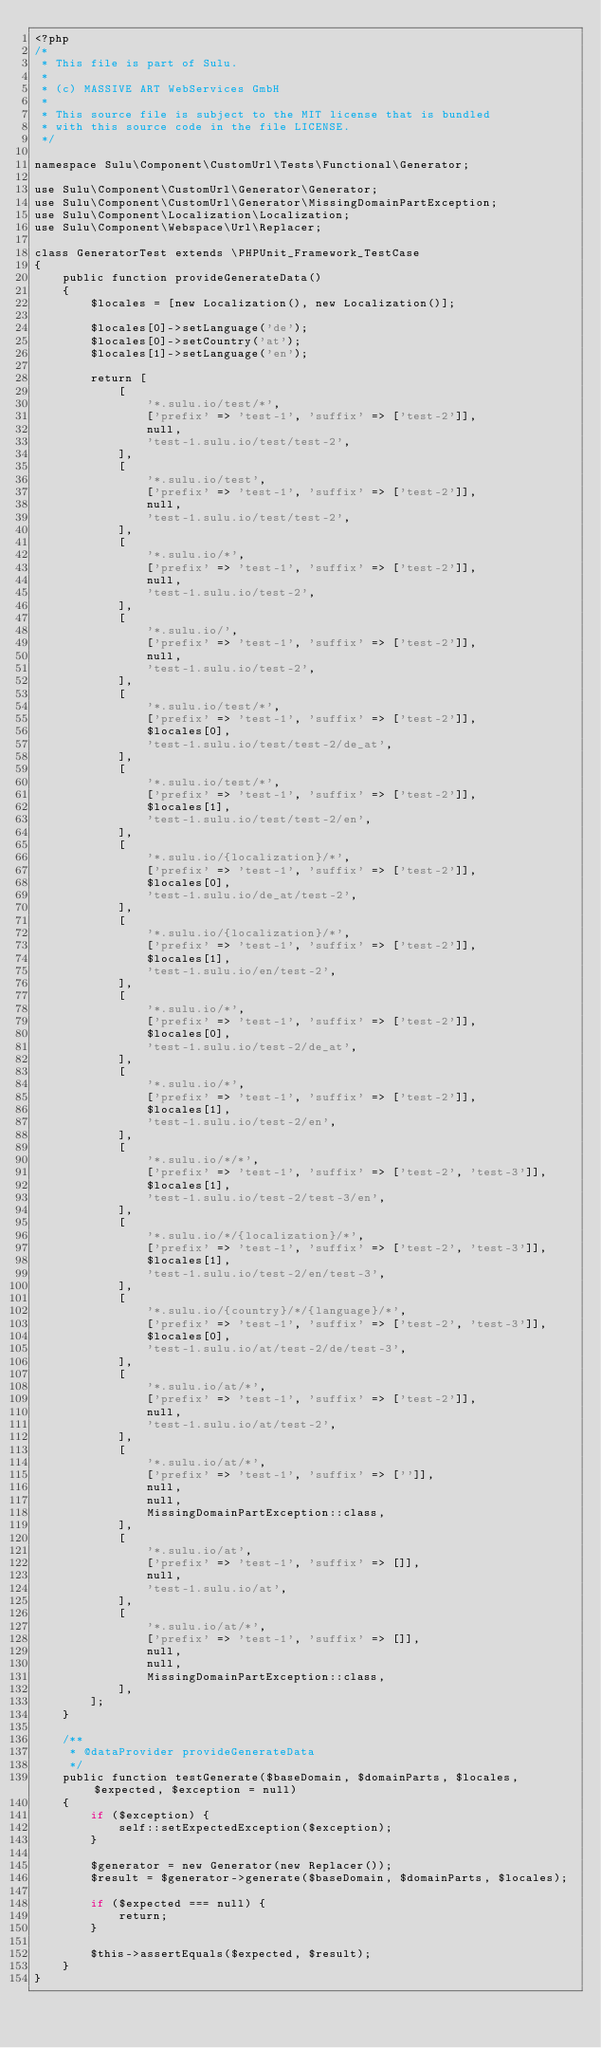<code> <loc_0><loc_0><loc_500><loc_500><_PHP_><?php
/*
 * This file is part of Sulu.
 *
 * (c) MASSIVE ART WebServices GmbH
 *
 * This source file is subject to the MIT license that is bundled
 * with this source code in the file LICENSE.
 */

namespace Sulu\Component\CustomUrl\Tests\Functional\Generator;

use Sulu\Component\CustomUrl\Generator\Generator;
use Sulu\Component\CustomUrl\Generator\MissingDomainPartException;
use Sulu\Component\Localization\Localization;
use Sulu\Component\Webspace\Url\Replacer;

class GeneratorTest extends \PHPUnit_Framework_TestCase
{
    public function provideGenerateData()
    {
        $locales = [new Localization(), new Localization()];

        $locales[0]->setLanguage('de');
        $locales[0]->setCountry('at');
        $locales[1]->setLanguage('en');

        return [
            [
                '*.sulu.io/test/*',
                ['prefix' => 'test-1', 'suffix' => ['test-2']],
                null,
                'test-1.sulu.io/test/test-2',
            ],
            [
                '*.sulu.io/test',
                ['prefix' => 'test-1', 'suffix' => ['test-2']],
                null,
                'test-1.sulu.io/test/test-2',
            ],
            [
                '*.sulu.io/*',
                ['prefix' => 'test-1', 'suffix' => ['test-2']],
                null,
                'test-1.sulu.io/test-2',
            ],
            [
                '*.sulu.io/',
                ['prefix' => 'test-1', 'suffix' => ['test-2']],
                null,
                'test-1.sulu.io/test-2',
            ],
            [
                '*.sulu.io/test/*',
                ['prefix' => 'test-1', 'suffix' => ['test-2']],
                $locales[0],
                'test-1.sulu.io/test/test-2/de_at',
            ],
            [
                '*.sulu.io/test/*',
                ['prefix' => 'test-1', 'suffix' => ['test-2']],
                $locales[1],
                'test-1.sulu.io/test/test-2/en',
            ],
            [
                '*.sulu.io/{localization}/*',
                ['prefix' => 'test-1', 'suffix' => ['test-2']],
                $locales[0],
                'test-1.sulu.io/de_at/test-2',
            ],
            [
                '*.sulu.io/{localization}/*',
                ['prefix' => 'test-1', 'suffix' => ['test-2']],
                $locales[1],
                'test-1.sulu.io/en/test-2',
            ],
            [
                '*.sulu.io/*',
                ['prefix' => 'test-1', 'suffix' => ['test-2']],
                $locales[0],
                'test-1.sulu.io/test-2/de_at',
            ],
            [
                '*.sulu.io/*',
                ['prefix' => 'test-1', 'suffix' => ['test-2']],
                $locales[1],
                'test-1.sulu.io/test-2/en',
            ],
            [
                '*.sulu.io/*/*',
                ['prefix' => 'test-1', 'suffix' => ['test-2', 'test-3']],
                $locales[1],
                'test-1.sulu.io/test-2/test-3/en',
            ],
            [
                '*.sulu.io/*/{localization}/*',
                ['prefix' => 'test-1', 'suffix' => ['test-2', 'test-3']],
                $locales[1],
                'test-1.sulu.io/test-2/en/test-3',
            ],
            [
                '*.sulu.io/{country}/*/{language}/*',
                ['prefix' => 'test-1', 'suffix' => ['test-2', 'test-3']],
                $locales[0],
                'test-1.sulu.io/at/test-2/de/test-3',
            ],
            [
                '*.sulu.io/at/*',
                ['prefix' => 'test-1', 'suffix' => ['test-2']],
                null,
                'test-1.sulu.io/at/test-2',
            ],
            [
                '*.sulu.io/at/*',
                ['prefix' => 'test-1', 'suffix' => ['']],
                null,
                null,
                MissingDomainPartException::class,
            ],
            [
                '*.sulu.io/at',
                ['prefix' => 'test-1', 'suffix' => []],
                null,
                'test-1.sulu.io/at',
            ],
            [
                '*.sulu.io/at/*',
                ['prefix' => 'test-1', 'suffix' => []],
                null,
                null,
                MissingDomainPartException::class,
            ],
        ];
    }

    /**
     * @dataProvider provideGenerateData
     */
    public function testGenerate($baseDomain, $domainParts, $locales, $expected, $exception = null)
    {
        if ($exception) {
            self::setExpectedException($exception);
        }

        $generator = new Generator(new Replacer());
        $result = $generator->generate($baseDomain, $domainParts, $locales);

        if ($expected === null) {
            return;
        }

        $this->assertEquals($expected, $result);
    }
}
</code> 